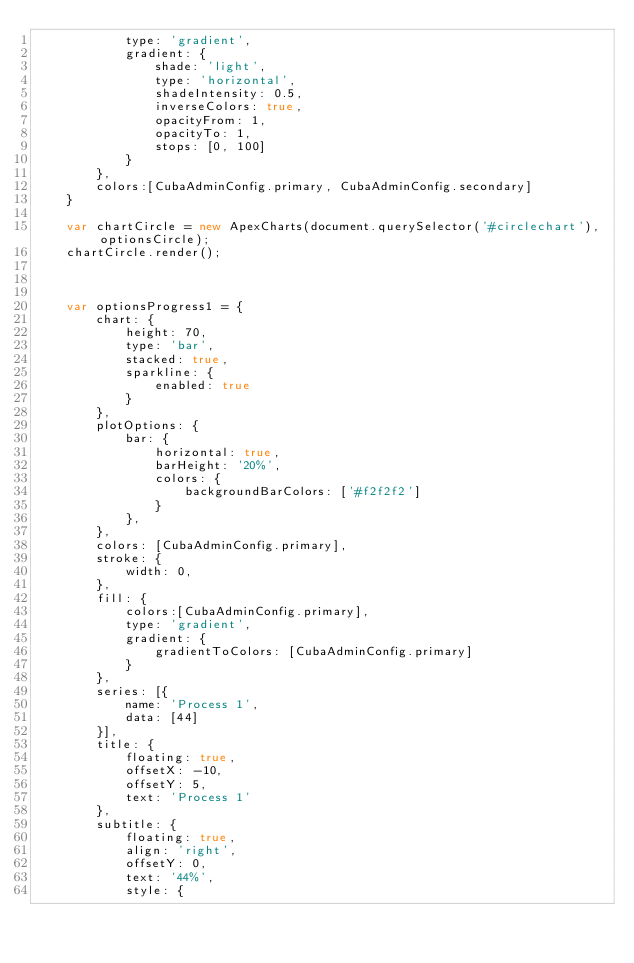<code> <loc_0><loc_0><loc_500><loc_500><_JavaScript_>            type: 'gradient',
            gradient: {
                shade: 'light',
                type: 'horizontal',
                shadeIntensity: 0.5,
                inverseColors: true,
                opacityFrom: 1,
                opacityTo: 1,
                stops: [0, 100]
            }
        },
        colors:[CubaAdminConfig.primary, CubaAdminConfig.secondary]
    }

    var chartCircle = new ApexCharts(document.querySelector('#circlechart'), optionsCircle);
    chartCircle.render();



    var optionsProgress1 = {
        chart: {
            height: 70,
            type: 'bar',
            stacked: true,
            sparkline: {
                enabled: true
            }
        },
        plotOptions: {
            bar: {
                horizontal: true,
                barHeight: '20%',
                colors: {
                    backgroundBarColors: ['#f2f2f2']
                }
            },
        },
        colors: [CubaAdminConfig.primary],
        stroke: {
            width: 0,
        },
        fill: {
            colors:[CubaAdminConfig.primary],
            type: 'gradient',
            gradient: {
                gradientToColors: [CubaAdminConfig.primary]
            }
        },
        series: [{
            name: 'Process 1',
            data: [44]
        }],
        title: {
            floating: true,
            offsetX: -10,
            offsetY: 5,
            text: 'Process 1'
        },
        subtitle: {
            floating: true,
            align: 'right',
            offsetY: 0,
            text: '44%',
            style: {</code> 